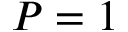Convert formula to latex. <formula><loc_0><loc_0><loc_500><loc_500>P = 1</formula> 